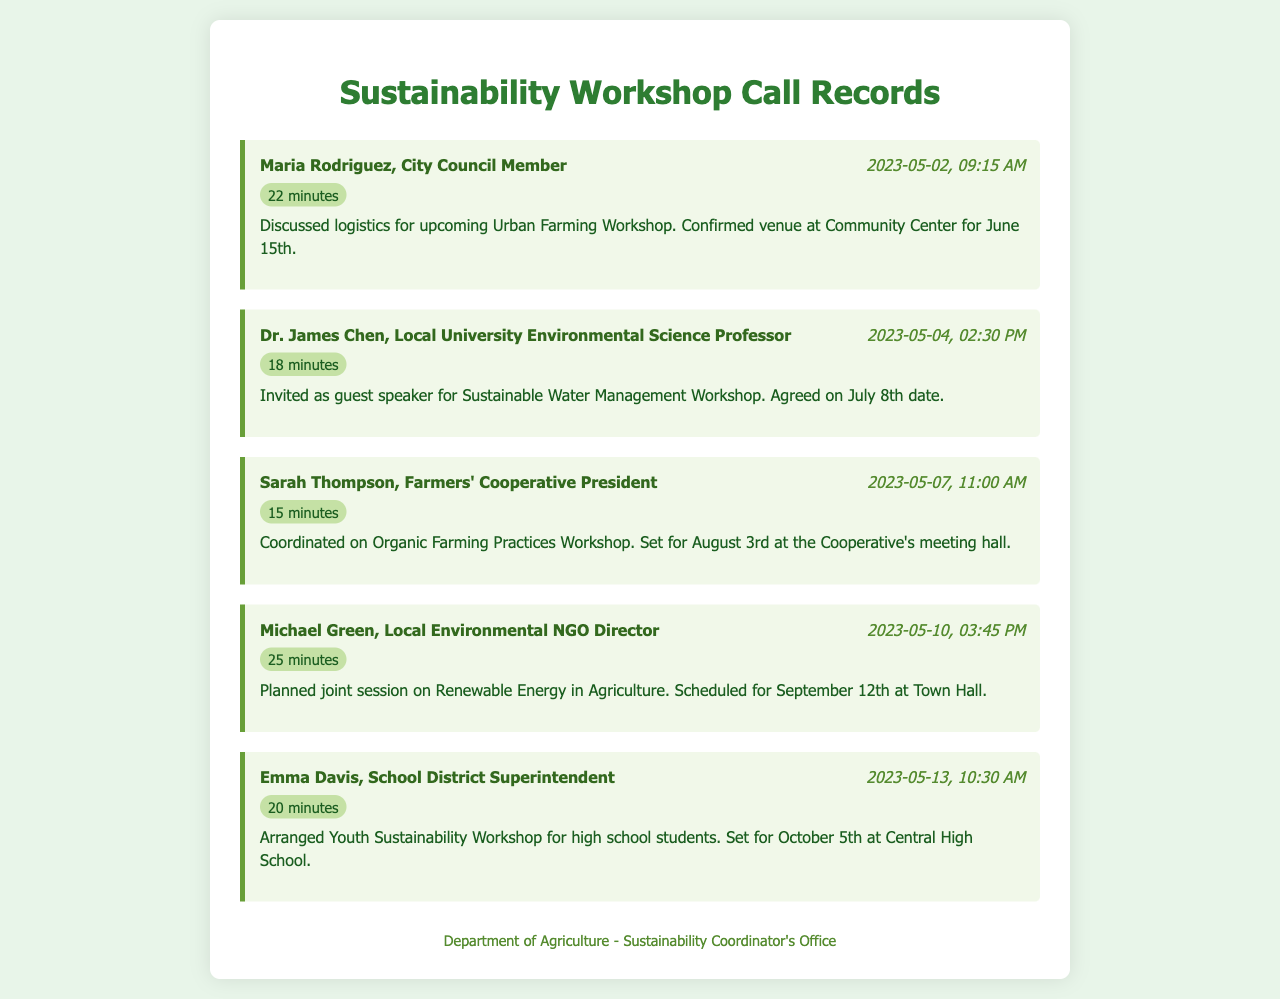what is the date of the Urban Farming Workshop? The date for the Urban Farming Workshop is mentioned in the notes of the call record with Maria Rodriguez.
Answer: June 15th who is the guest speaker for the Sustainable Water Management Workshop? Dr. James Chen is invited as the guest speaker for the Sustainable Water Management Workshop according to the call record.
Answer: Dr. James Chen how long was the call with Sarah Thompson? The duration of the call with Sarah Thompson is stated in the call record.
Answer: 15 minutes when is the scheduled date for the Renewable Energy in Agriculture session? The date for the Renewable Energy in Agriculture session is mentioned in the call record with Michael Green.
Answer: September 12th who was involved in arranging the Youth Sustainability Workshop? The arrangement for the Youth Sustainability Workshop was discussed with Emma Davis, as indicated in the call record.
Answer: Emma Davis how many workshops are scheduled for the month of August? There is one workshop scheduled for August, which is mentioned in the call record with Sarah Thompson.
Answer: 1 what is the call duration for the discussion with Dr. James Chen? The duration of the call with Dr. James Chen is mentioned in the call record.
Answer: 18 minutes where will the Organic Farming Practices Workshop take place? The location for the Organic Farming Practices Workshop is stated in the call record with Sarah Thompson.
Answer: Cooperative's meeting hall who initiated the call regarding logistics for the Urban Farming Workshop? The note indicates that Maria Rodriguez was the contact for the call about the Urban Farming Workshop logistics.
Answer: Maria Rodriguez 